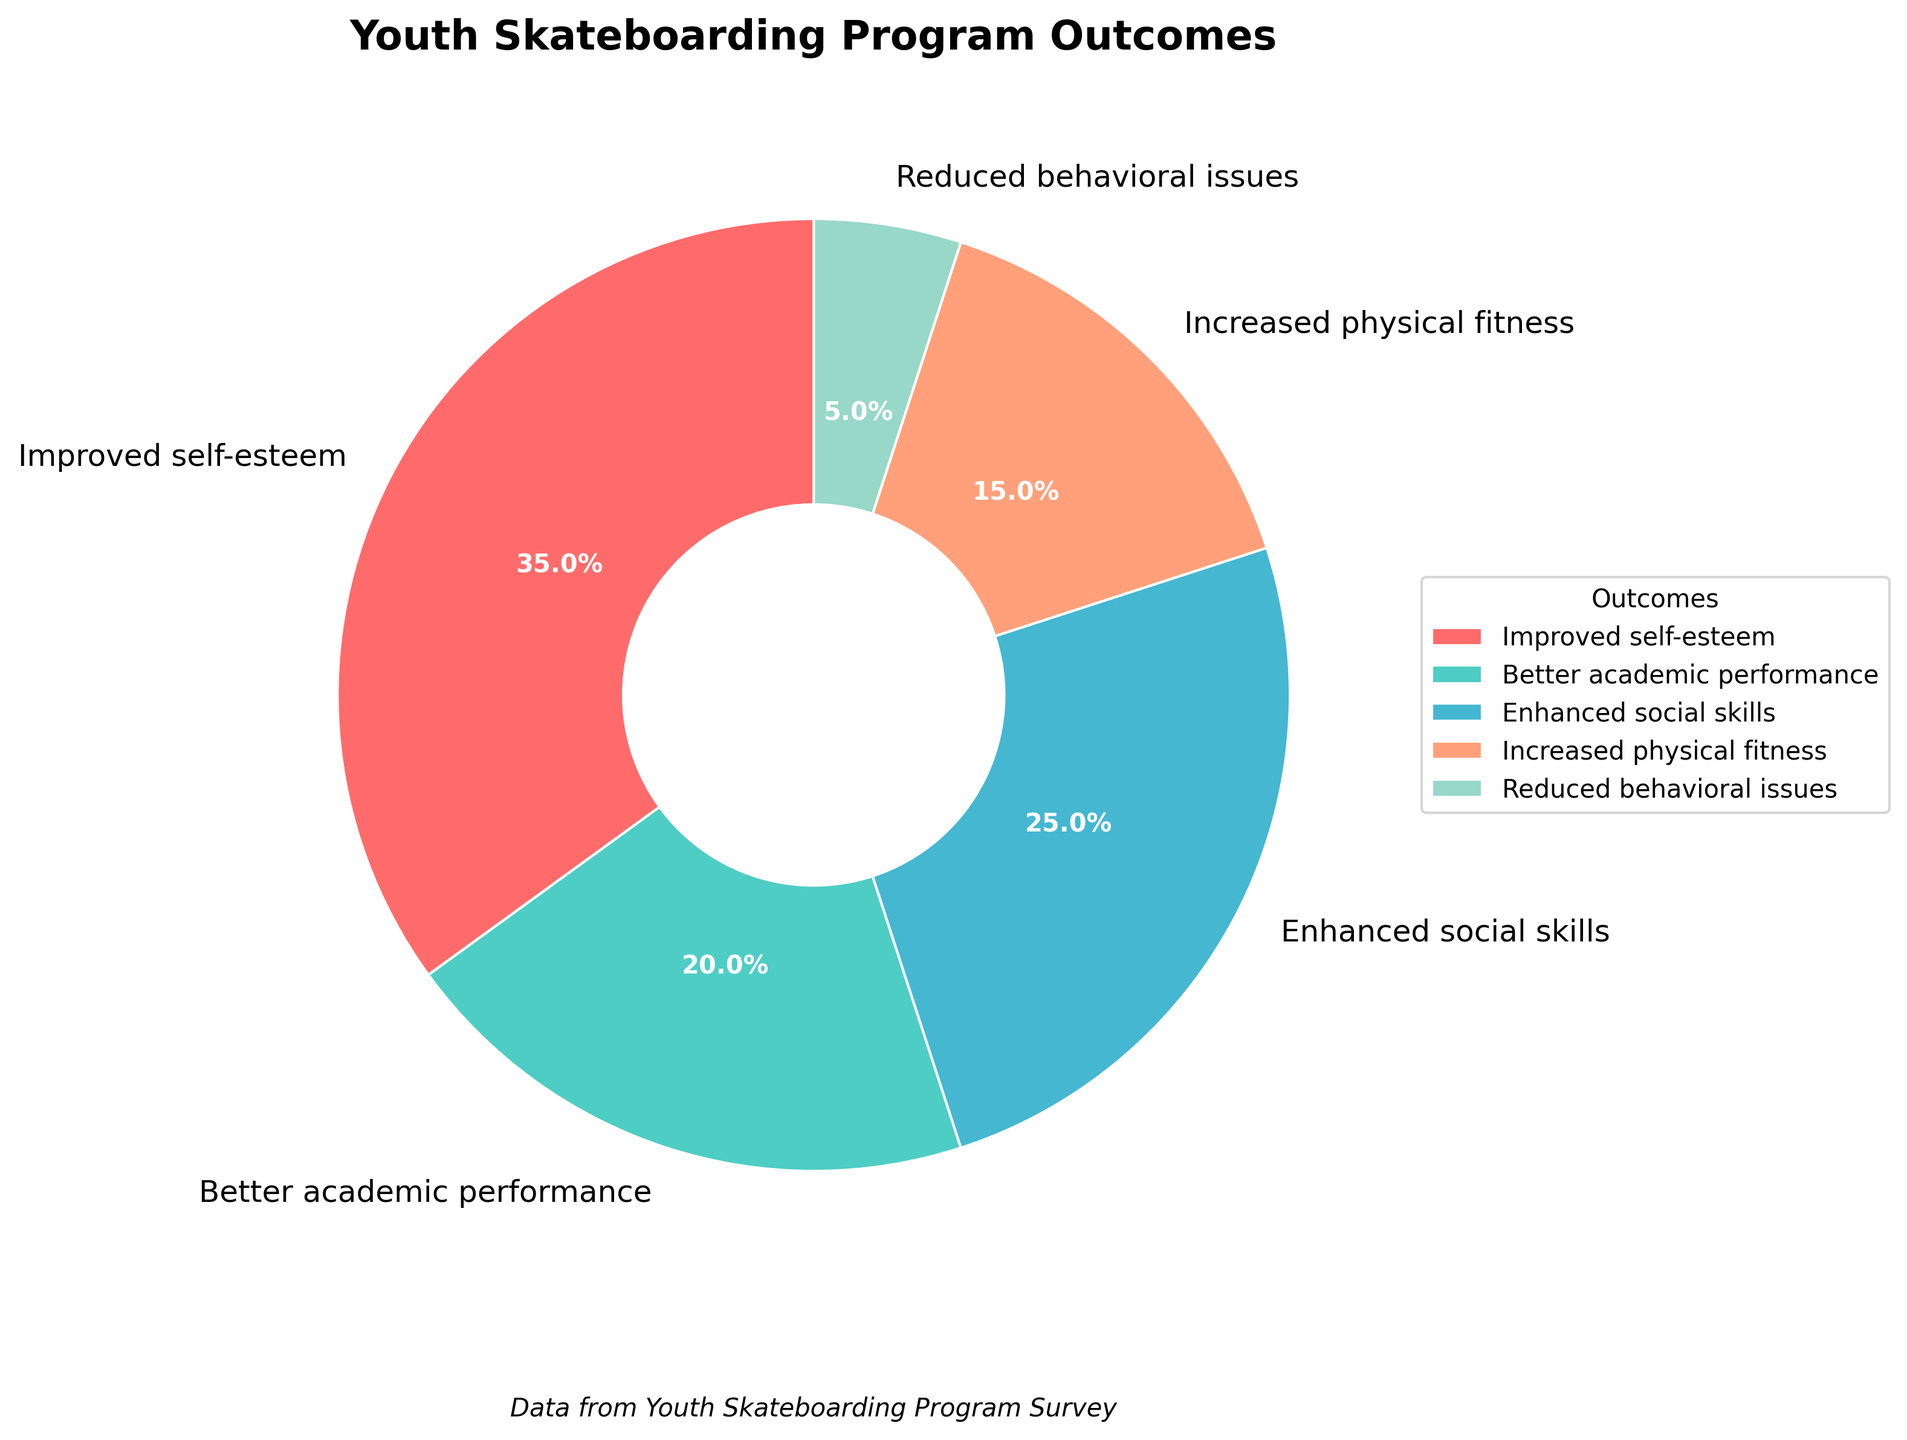What is the percentage of youth participants who reported improved self-esteem? Look at the figure and find the segment labeled "Improved self-esteem". The percentage value associated with it is 35%.
Answer: 35% Which outcome has the lowest reported percentage? Look at the figure and identify the segment with the smallest slice. It is labeled "Reduced behavioral issues" with a percentage of 5%.
Answer: Reduced behavioral issues How much greater is the percentage of youth reporting improved self-esteem compared to those reporting increased physical fitness? Find the percentage of both outcomes: Improved self-esteem is 35%, and Increased physical fitness is 15%. Subtract the latter from the former: 35% - 15% = 20%.
Answer: 20% What is the combined percentage of youth who reported improved self-esteem and enhanced social skills? Find the percentage for both outcomes: Improved self-esteem is 35%, and Enhanced social skills is 25%. Add them together: 35% + 25% = 60%.
Answer: 60% Which outcome has a greater percentage, better academic performance or enhanced social skills? Compare the two percentages: Better academic performance is 20% and Enhanced social skills is 25%. Enhanced social skills is greater.
Answer: Enhanced social skills What is the total percentage of outcomes excluding reduced behavioral issues? Exclude the percentage for reduced behavioral issues (5%) and sum the remaining percentages: 35% + 20% + 25% + 15% = 95%.
Answer: 95% What is the order of the outcomes from highest to lowest percentage? List the outcomes according to their percentage values: Improved self-esteem (35%), Enhanced social skills (25%), Better academic performance (20%), Increased physical fitness (15%), Reduced behavioral issues (5%).
Answer: Improved self-esteem, Enhanced social skills, Better academic performance, Increased physical fitness, Reduced behavioral issues If an outcome is selected at random, what is the likelihood it represents better academic performance or enhanced social skills? Find the percentages for both outcomes and add them: Better academic performance is 20%, and Enhanced social skills is 25%. The combined percentage is 20% + 25% = 45%.
Answer: 45% 